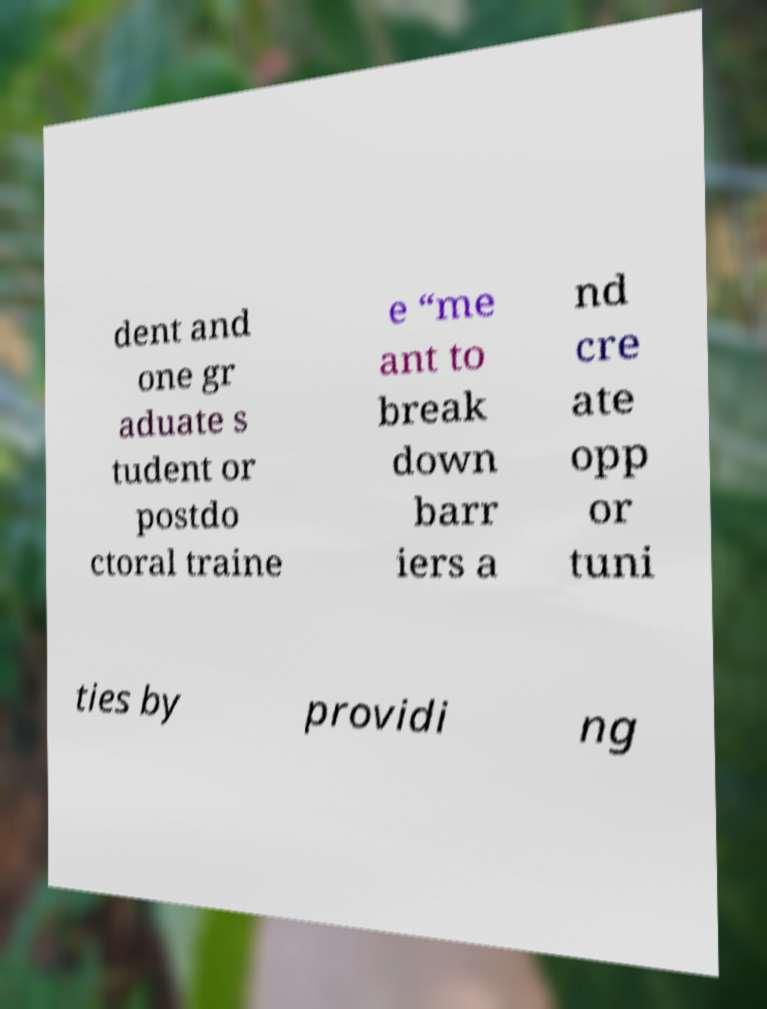Can you read and provide the text displayed in the image?This photo seems to have some interesting text. Can you extract and type it out for me? dent and one gr aduate s tudent or postdo ctoral traine e “me ant to break down barr iers a nd cre ate opp or tuni ties by providi ng 